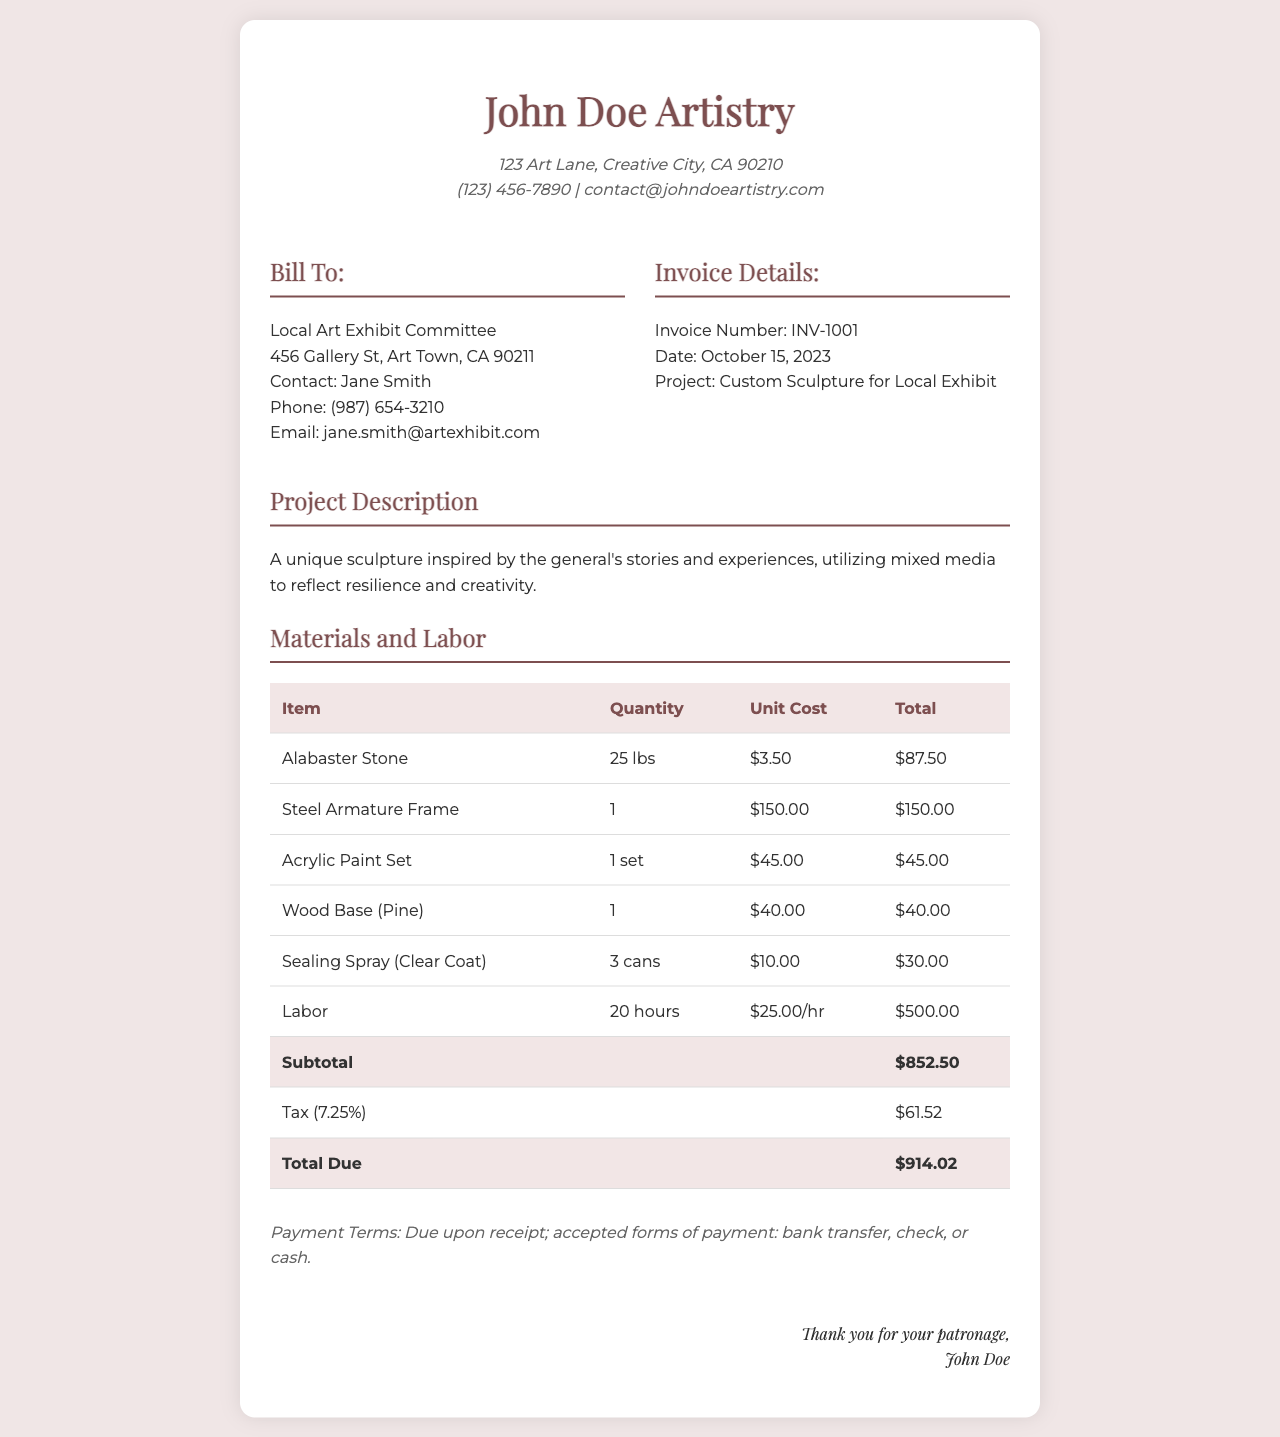What is the invoice number? The invoice number is listed in the invoice details section, which specifically states "Invoice Number: INV-1001".
Answer: INV-1001 What is the total due amount? The total due amount is presented at the end of the materials and labor table, marked as "Total Due", which amounts to $914.02.
Answer: $914.02 Who is the client for this invoice? The client information is provided under the "Bill To" section, indicating "Local Art Exhibit Committee".
Answer: Local Art Exhibit Committee What date was the invoice issued? The date is found in the invoice details, specifically stated as "Date: October 15, 2023".
Answer: October 15, 2023 How many hours of labor were billed? The number of labor hours is specified in the materials and labor section, stating "Labor: 20 hours".
Answer: 20 hours What is the subtotal before tax? The subtotal is shown in the total row of the materials and labor table, clearly stated as "Subtotal: $852.50".
Answer: $852.50 What type of paint was used in the sculpture? The invoice lists "Acrylic Paint Set" under materials, indicating that this specific type of paint was used.
Answer: Acrylic Paint Set What is the contact email for the artist? The artist's contact email is listed in the header of the document, noted as "contact@johndoeartistry.com".
Answer: contact@johndoeartistry.com What are the payment terms? The payment terms are included at the bottom of the invoice, specifically stated as "Due upon receipt".
Answer: Due upon receipt 